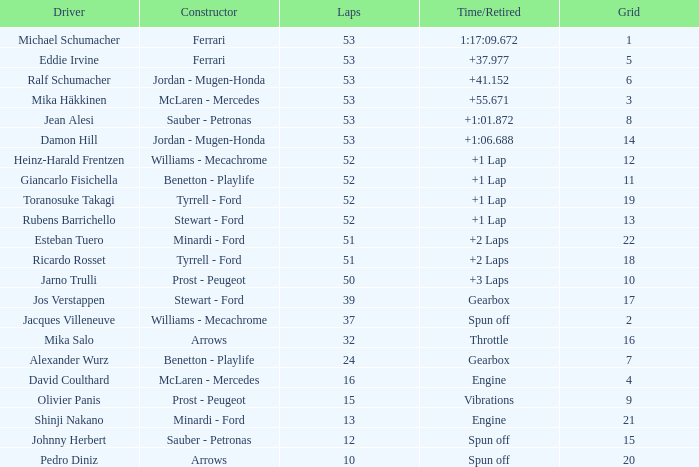After 53 laps, what is the cumulative grid number for ralf schumacher's race? None. 